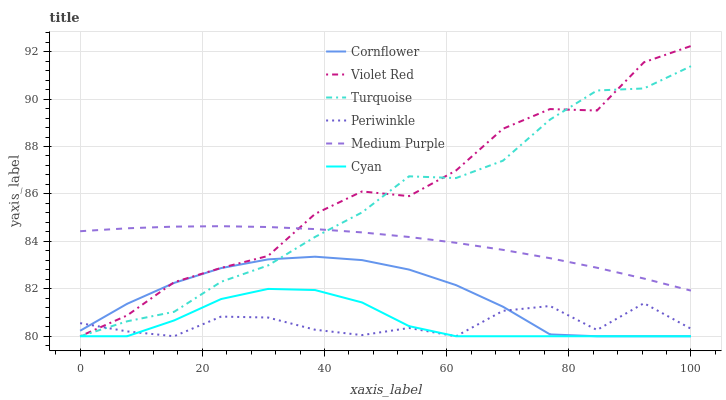Does Periwinkle have the minimum area under the curve?
Answer yes or no. Yes. Does Violet Red have the maximum area under the curve?
Answer yes or no. Yes. Does Turquoise have the minimum area under the curve?
Answer yes or no. No. Does Turquoise have the maximum area under the curve?
Answer yes or no. No. Is Medium Purple the smoothest?
Answer yes or no. Yes. Is Violet Red the roughest?
Answer yes or no. Yes. Is Turquoise the smoothest?
Answer yes or no. No. Is Turquoise the roughest?
Answer yes or no. No. Does Medium Purple have the lowest value?
Answer yes or no. No. Does Violet Red have the highest value?
Answer yes or no. Yes. Does Turquoise have the highest value?
Answer yes or no. No. Is Cornflower less than Medium Purple?
Answer yes or no. Yes. Is Medium Purple greater than Cornflower?
Answer yes or no. Yes. Does Medium Purple intersect Turquoise?
Answer yes or no. Yes. Is Medium Purple less than Turquoise?
Answer yes or no. No. Is Medium Purple greater than Turquoise?
Answer yes or no. No. Does Cornflower intersect Medium Purple?
Answer yes or no. No. 